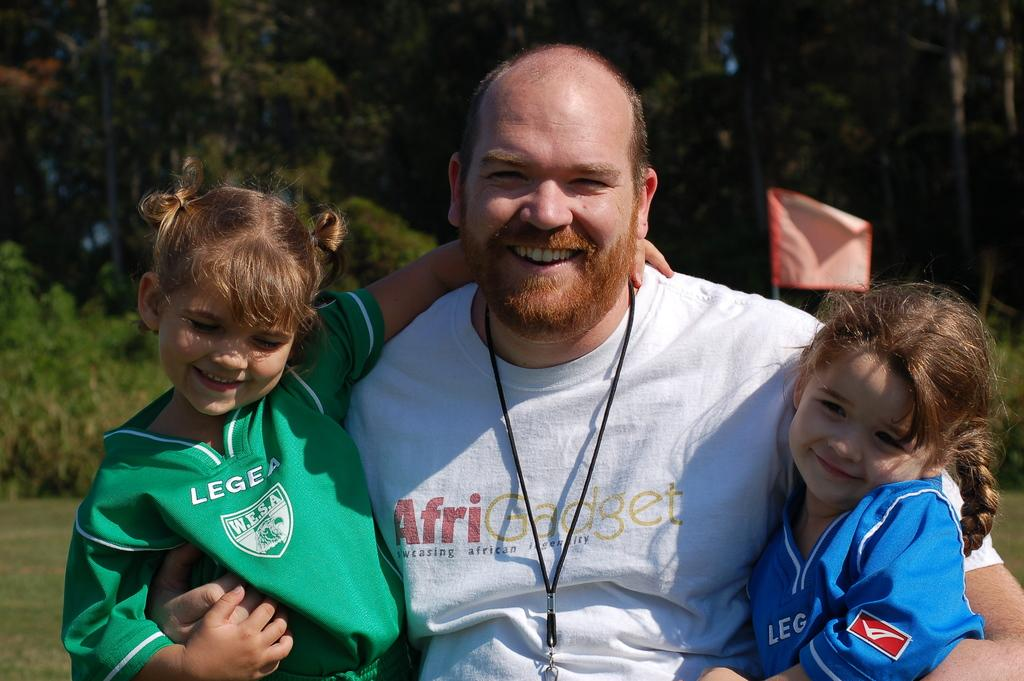<image>
Give a short and clear explanation of the subsequent image. A man with his arms around two children, one of whom is wearing a Legea shirt. 